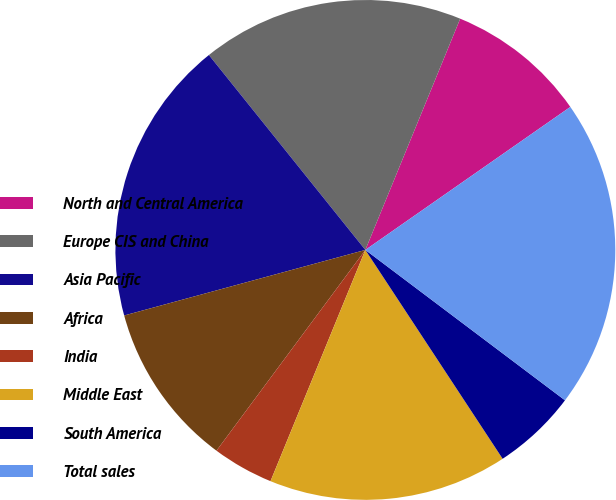<chart> <loc_0><loc_0><loc_500><loc_500><pie_chart><fcel>North and Central America<fcel>Europe CIS and China<fcel>Asia Pacific<fcel>Africa<fcel>India<fcel>Middle East<fcel>South America<fcel>Total sales<nl><fcel>9.11%<fcel>16.96%<fcel>18.46%<fcel>10.62%<fcel>3.96%<fcel>15.45%<fcel>5.47%<fcel>19.97%<nl></chart> 